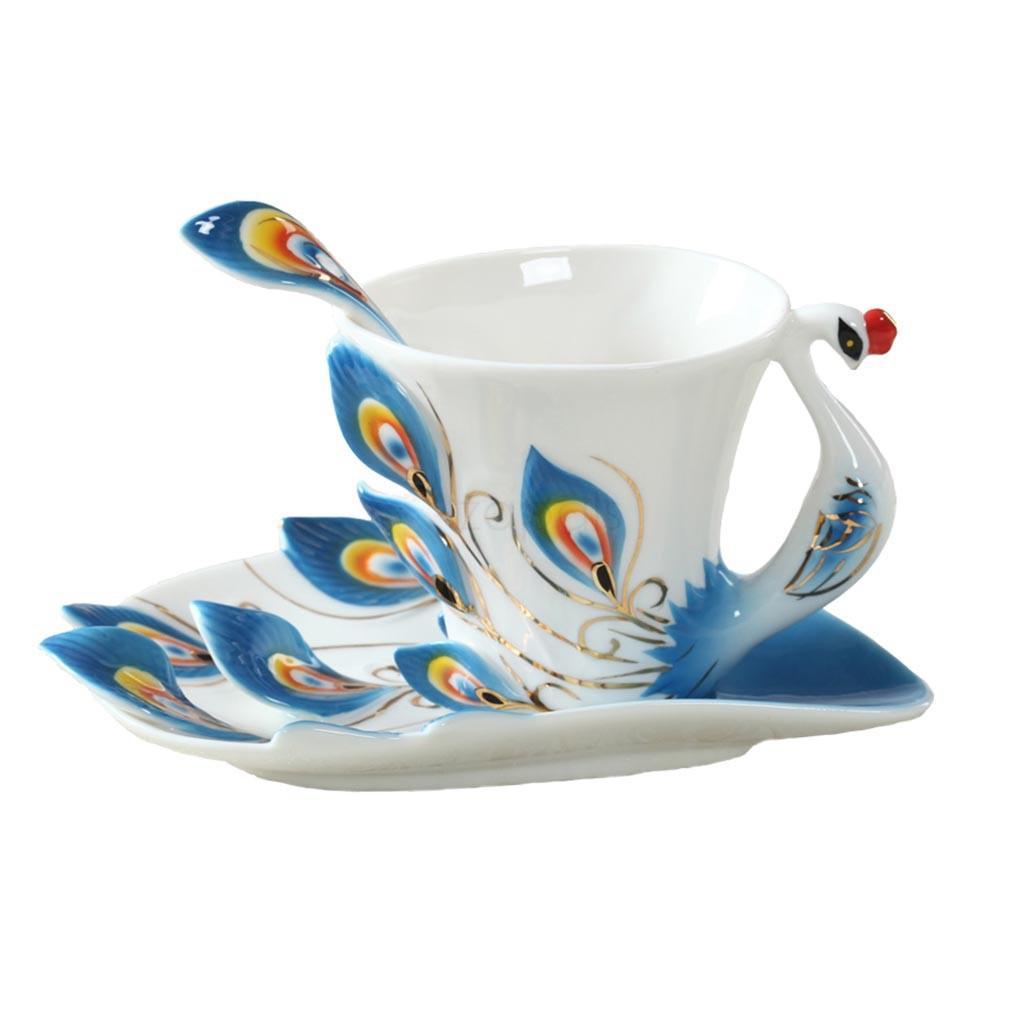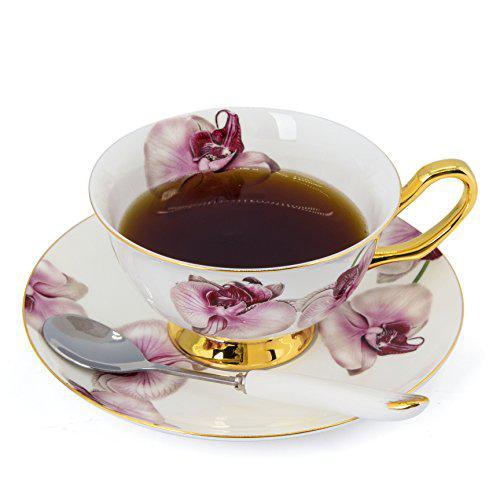The first image is the image on the left, the second image is the image on the right. Examine the images to the left and right. Is the description "One of the cups has flowers printed on it." accurate? Answer yes or no. Yes. 